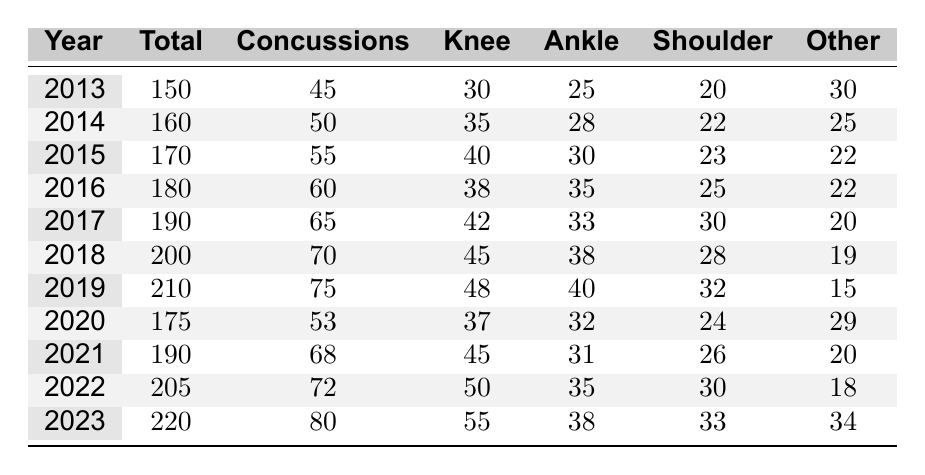What year had the highest number of total injuries? The table shows the total injuries for each year. By examining the "Total" column, I can see that 2023 has the highest number at 220.
Answer: 2023 How many concussions were reported in 2016? The table lists concussions for each year, and for 2016, it shows 60 concussions.
Answer: 60 What was the percentage increase in total injuries from 2013 to 2023? In 2013, there were 150 total injuries and in 2023, there were 220. The percentage increase is calculated as ((220 - 150) / 150) * 100 = (70 / 150) * 100, which gives roughly 46.67%.
Answer: 46.67% True or False: The number of knee injuries decreased from 2014 to 2015. By looking at the knee injuries for 2014 (35) and 2015 (40), I see that the number of knee injuries actually increased, so the statement is false.
Answer: False What is the total number of other injuries recorded in 2022? In the year 2022, the table shows 18 injuries categorized as "Other."
Answer: 18 How many more concussions were recorded in 2023 compared to 2019? The table states that there were 75 concussions in 2019 and 80 in 2023. The difference is 80 - 75 = 5.
Answer: 5 Which year recorded the least number of shoulder injuries? Reviewing the "Shoulder" column, I see that 2018 had the least number at 19 injuries.
Answer: 2018 What is the average number of ankle injuries from 2013 to 2023? To find the average, I sum the ankle injuries from each year (25 + 28 + 30 + 35 + 33 + 38 + 40 + 32 + 35 + 38) which equals  319. There are 11 years, so the average is 319 / 11, which is approximately 29.00.
Answer: 29 What was the trend in the total number of injuries from 2013 to 2023? By examining the "Total" column, I notice that the number of injuries increased every year, indicating a trend of increasing injuries over the decade.
Answer: Increasing 